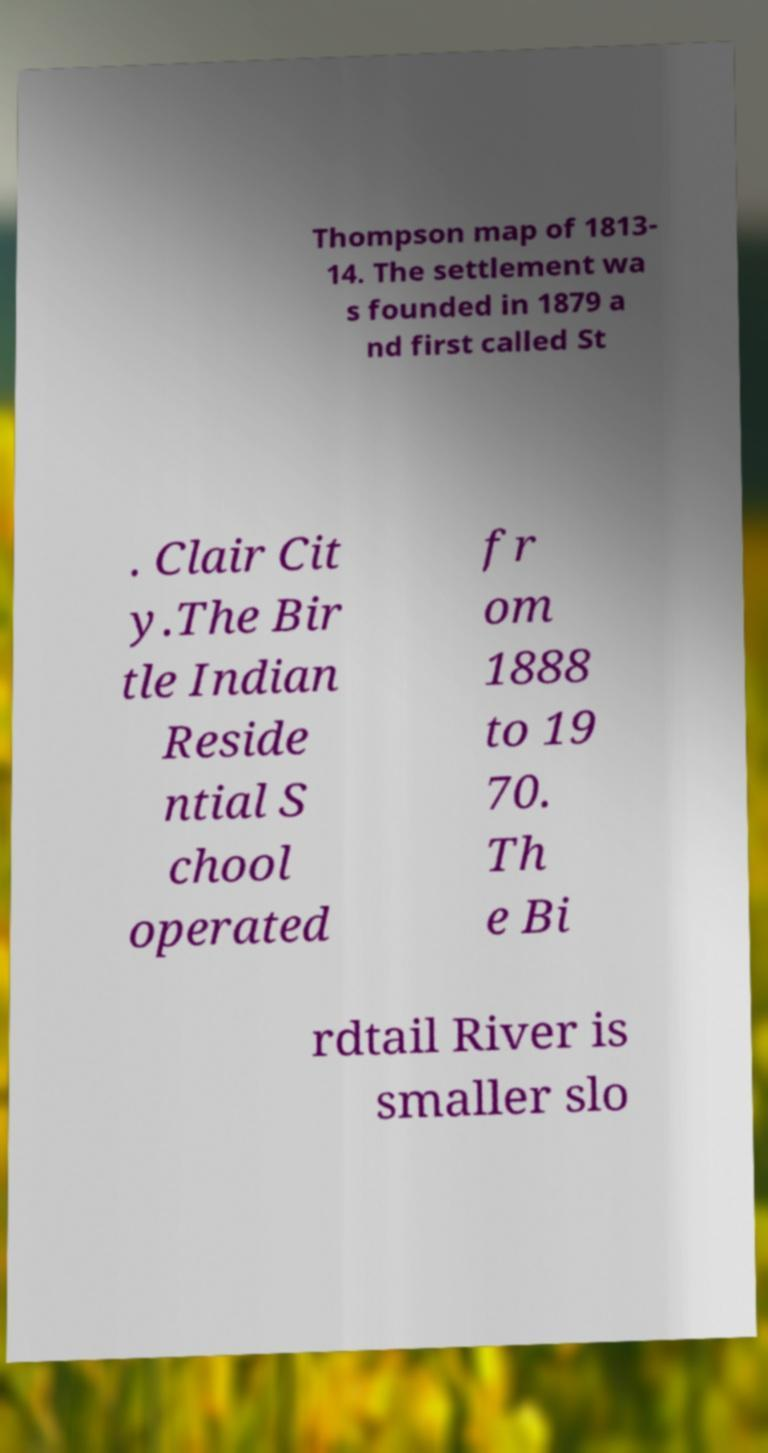Please read and relay the text visible in this image. What does it say? Thompson map of 1813- 14. The settlement wa s founded in 1879 a nd first called St . Clair Cit y.The Bir tle Indian Reside ntial S chool operated fr om 1888 to 19 70. Th e Bi rdtail River is smaller slo 